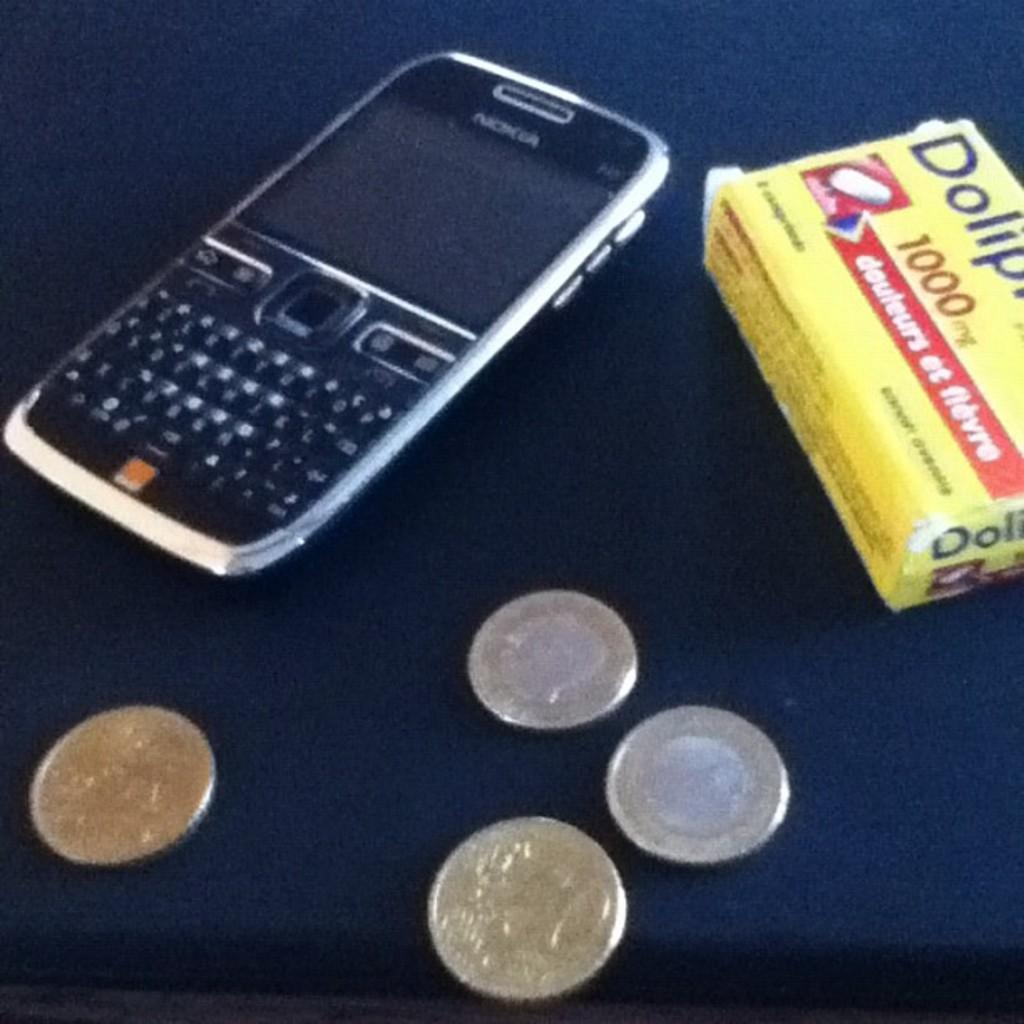<image>
Summarize the visual content of the image. A bot of 1000 pills is next to a phone. 